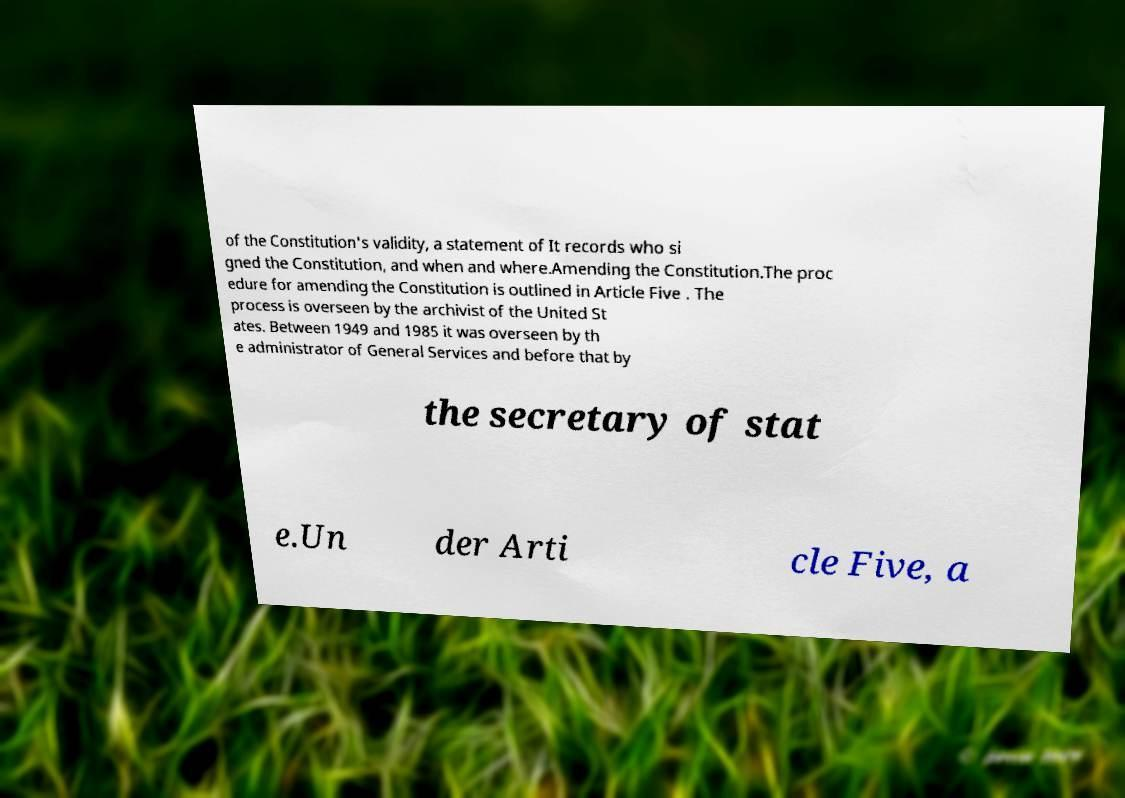Please identify and transcribe the text found in this image. of the Constitution's validity, a statement of It records who si gned the Constitution, and when and where.Amending the Constitution.The proc edure for amending the Constitution is outlined in Article Five . The process is overseen by the archivist of the United St ates. Between 1949 and 1985 it was overseen by th e administrator of General Services and before that by the secretary of stat e.Un der Arti cle Five, a 